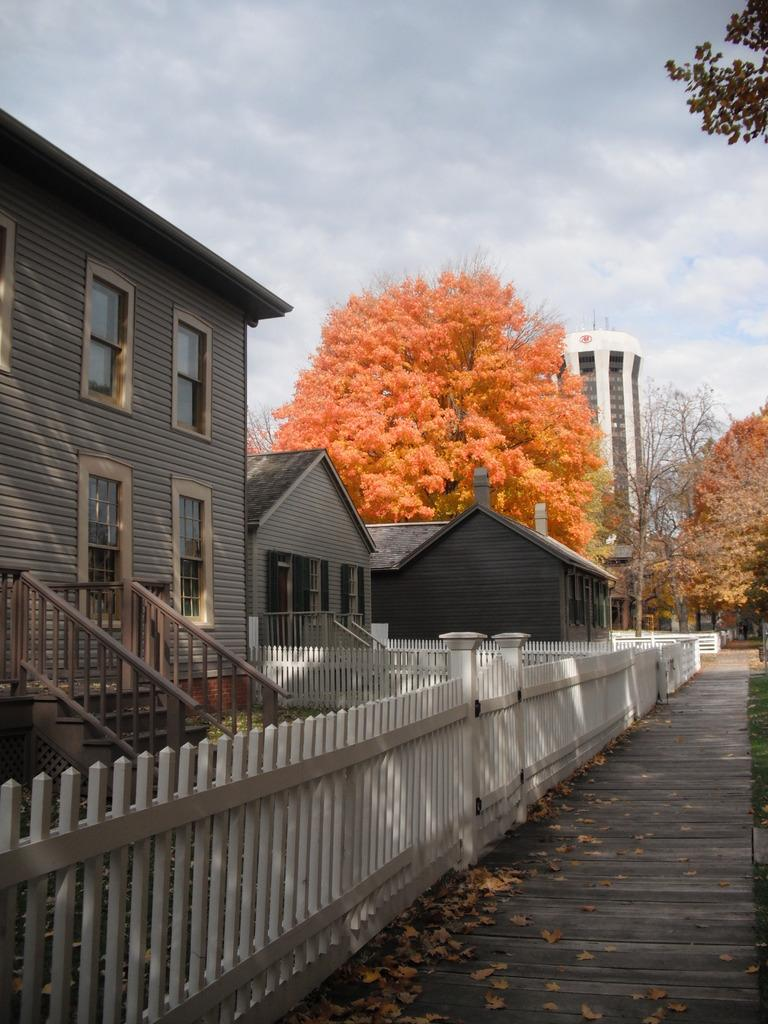What type of structures can be seen in the image? There are buildings in the image. What architectural features are present in the image? There are windows, stairs, and fencing visible in the image. What type of vegetation is present in the image? There are trees in the image, and some of the leaves are orange, yellow, and green. What is the color of the sky in the image? The sky is blue and white in color. Can you describe the impulse that the snow is experiencing in the image? There is no snow present in the image, so it is not possible to describe any impulses it might be experiencing. What type of thrill can be seen in the image? There is no thrill depicted in the image; it features buildings, windows, stairs, fencing, trees, and a blue and white sky. 